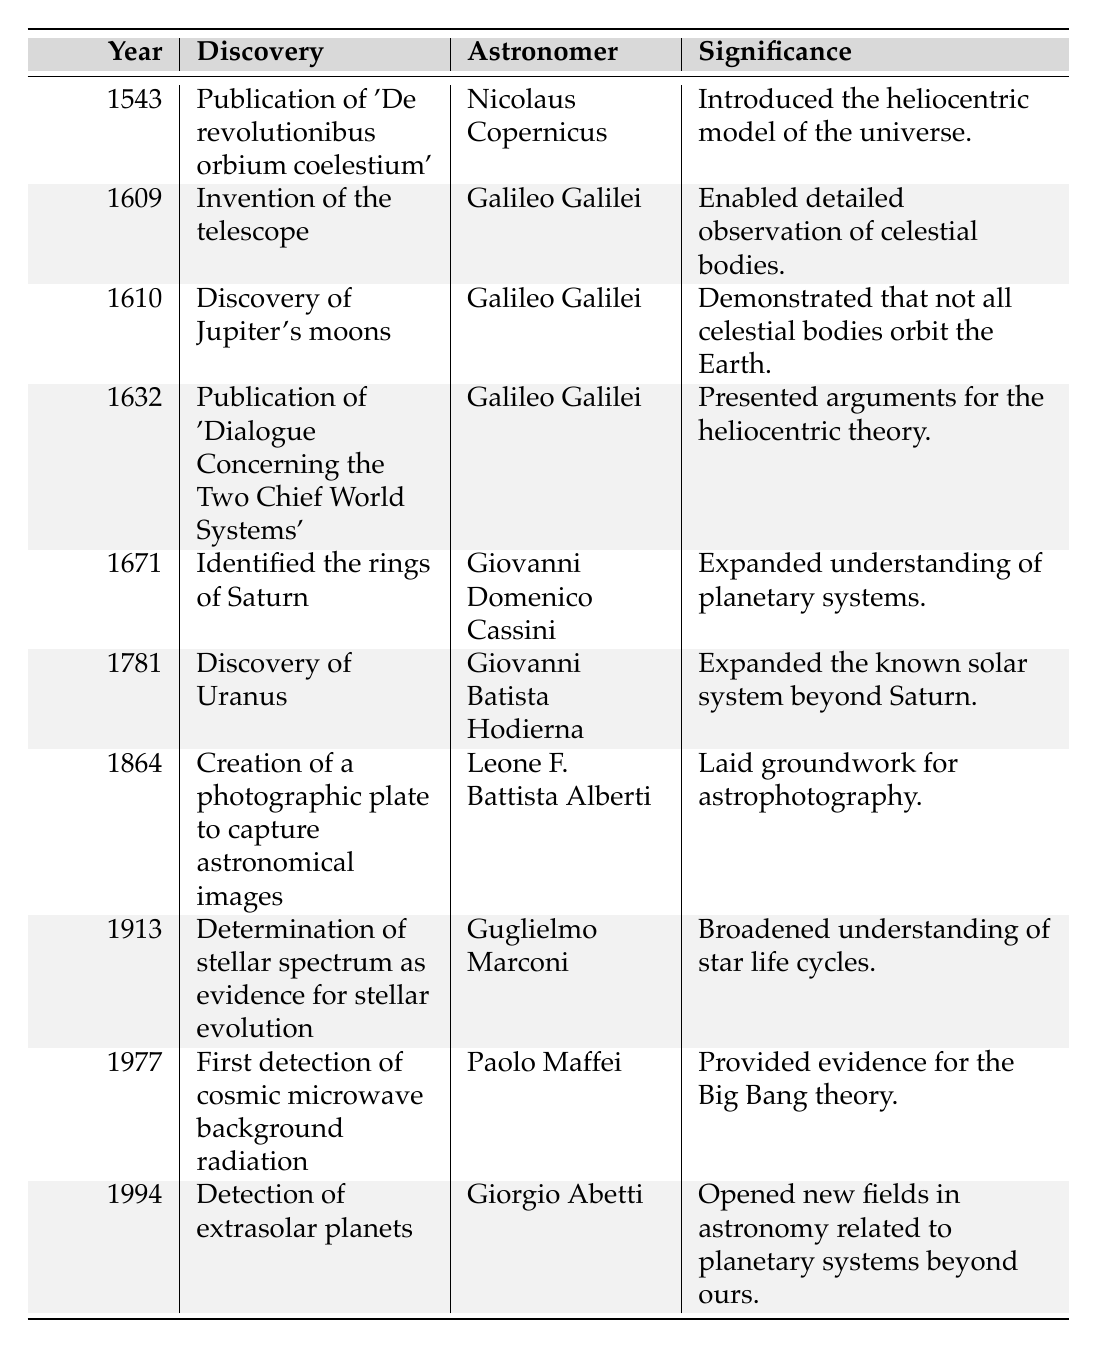What discovery did Nicolaus Copernicus publish in 1543? The table lists the discovery made by Nicolaus Copernicus in 1543 as the publication of 'De revolutionibus orbium coelestium'.
Answer: 'De revolutionibus orbium coelestium' Who invented the telescope, and in what year? The table indicates that the telescope was invented by Galileo Galilei in 1609.
Answer: Galileo Galilei in 1609 Which astronomer identified the rings of Saturn, and in what year? According to the table, Giovanni Domenico Cassini identified the rings of Saturn in 1671.
Answer: Giovanni Domenico Cassini in 1671 What significant contribution to astronomy did Guglielmo Marconi make in 1913? The table notes that Guglielmo Marconi's contribution in 1913 was the determination of stellar spectrum as evidence for stellar evolution.
Answer: Determination of stellar spectrum as evidence for stellar evolution How many discoveries were made by Galileo Galilei according to the table? The table lists four discoveries by Galileo Galilei: invention of the telescope, discovery of Jupiter's moons, publication of 'Dialogue Concerning the Two Chief World Systems', and arguments for the heliocentric theory.
Answer: Four discoveries What is the earliest discovery listed in the table? The earliest discovery in the table is from the year 1543, which is the publication of 'De revolutionibus orbium coelestium' by Nicolaus Copernicus.
Answer: 1543 Which discoveries relate to the heliocentric model of the universe? The discoveries relating to the heliocentric model are the publication of 'De revolutionibus orbium coelestium' in 1543 by Copernicus and the arguments for the heliocentric theory in 1632 by Galileo Galilei.
Answer: Two discoveries What was the significance of the detection of extrasolar planets in 1994? The significance of the detection of extrasolar planets in 1994, made by Giorgio Abetti, is that it opened new fields in astronomy related to planetary systems beyond ours.
Answer: Opened new fields in astronomy Which discovery occurred first, the identification of the rings of Saturn or the discovery of Uranus? The identification of the rings of Saturn in 1671 occurred before the discovery of Uranus in 1781, as noted in the timeline.
Answer: Identification of rings of Saturn What was the difference in years between Galileo's invention of the telescope and the publication of 'Dialogue Concerning the Two Chief World Systems'? The invention of the telescope occurred in 1609, and the publication of 'Dialogue Concerning the Two Chief World Systems' occurred in 1632; thus, the difference is 1632 - 1609 = 23 years.
Answer: 23 years Was the first detection of cosmic microwave background radiation made in the 20th century? Yes, the first detection of cosmic microwave background radiation made by Paolo Maffei did occur in 1977, which is within the 20th century.
Answer: Yes Who made the discovery that broadened the understanding of star life cycles and what year did it occur? The discovery that broadened the understanding of star life cycles was made by Guglielmo Marconi in 1913, as per the table.
Answer: Guglielmo Marconi in 1913 